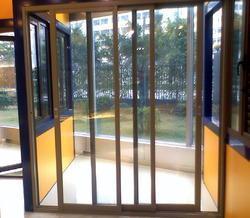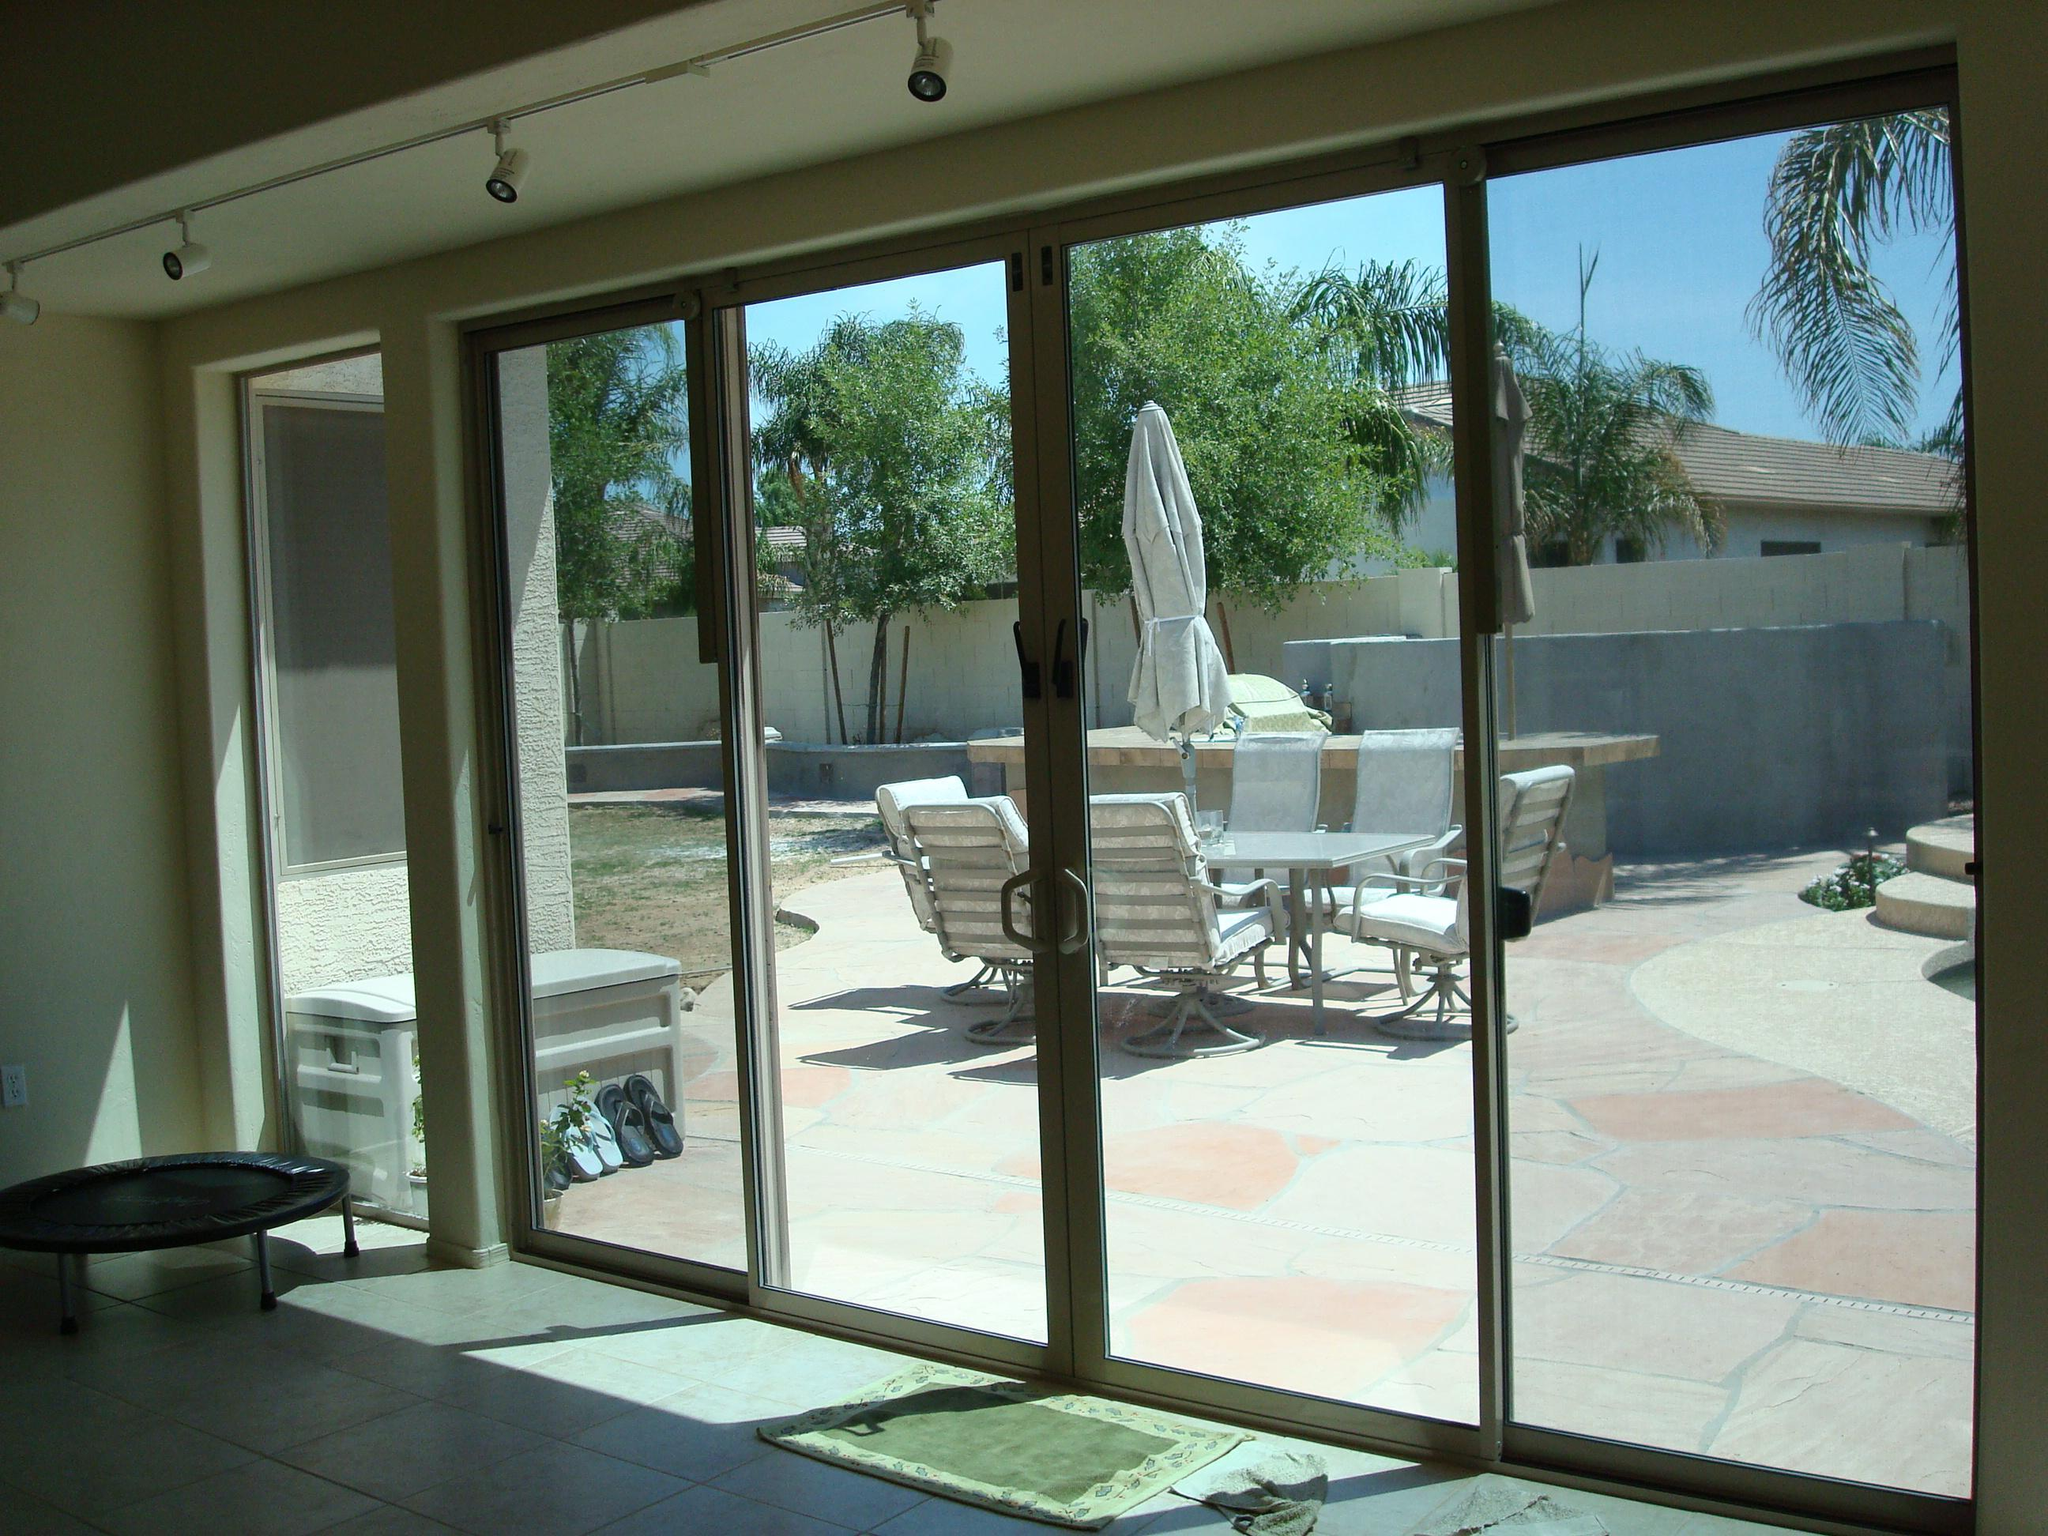The first image is the image on the left, the second image is the image on the right. For the images shown, is this caption "There is a table and chairs outside the door in the image on the left." true? Answer yes or no. No. The first image is the image on the left, the second image is the image on the right. Analyze the images presented: Is the assertion "A sliding glass door unit has three door-shaped sections and no door is open." valid? Answer yes or no. No. 